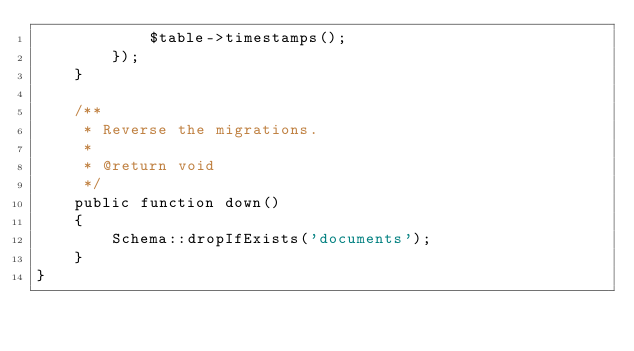<code> <loc_0><loc_0><loc_500><loc_500><_PHP_>            $table->timestamps();
        });
    }

    /**
     * Reverse the migrations.
     *
     * @return void
     */
    public function down()
    {
        Schema::dropIfExists('documents');
    }
}
</code> 